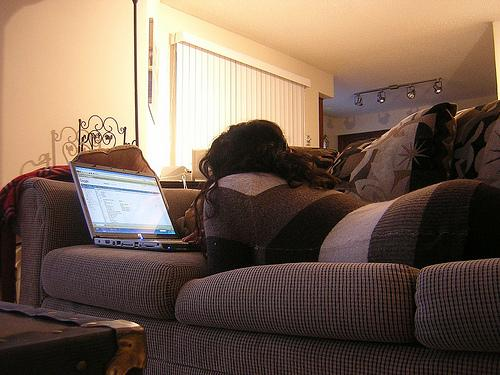Mention three key items on or by the couch other than the woman and the laptop. Pillows, a red and black blanket on the arm of the couch, and a gold star on a couch pillow. Identify the primary activity that the woman is engaged in. A woman is lying on a couch using her laptop. Mention three objects present on the couch along with the woman. A silver laptop, brown couch cushions, and patterned throw pillows. Describe the appearance and location of the window covering. White vertical blinds cover a doorway and a window, located behind the woman. What is the color and pattern of the throw pillows on the couch? The throw pillows have a brown, black, grey, and tan checkered pattern. Describe the appearance of the woman's hair and sweater. The woman has wavy black hair and is wearing a brown, black, and white striped sweater. Comment on the image's overall sentiment in relation to the position and actions of the central subject. The image conveys a sense of comfort and relaxation as the woman is lying on a couch using her laptop in a cozy space. Count the total number of cushions and pillows visible in the image. There are two brown couch cushions and two patterned throw pillows. Identify the type of table visible in the image and its position. There is a trunk coffee table near the floor, partially visible behind the couch. State the type of lighting used in the room along with their position. There are track lights and can lights hanging from the ceiling. What is the sentiment of the image? Is it positive, negative, or neutral? Neutral What color is the wall in the image?  Cream-colored What is the color of the woman's hair in the image?  Black Which items mentioned in the image have a width greater than 200?  Woman laying on a couch, woman using a laptop, laptop on a couch, girl on couch using laptop, brown and black checkered couch, woman on her stomach on a couch, a lady looking at a laptop, woman laying on a couch using her laptop, and fluffy brown couch cushions. Given these options, what is most likely the object referred to as "this is the pillow": (A) window blinds, (B) couch cushions, (C) decorative pillows, or (D) laptop? (C) decorative pillows How is the woman interacting with the laptop?  She is laying on the couch using her laptop.  What do the decorative couch pillows look like?  Brown, black, grey, and tan patterned throw pillows What type of table is visible in the image?  Trunk coffee table Identify any anomaly or unusual object in the image. There are no anomalies or unusual objects.  What type of object is directly below the track lighting?  Woman laying on a couch What is the main object a woman is interacting with in the image?  Laptop What text is visible in the image?  There is no visible text. In the image, are the couch cushions brown or green?  Brown Is the laptop on or off in the image?  On Rate the quality of the image on a scale of 1 to 10, with 1 being poor and 10 being excellent. 8 Describe the scene in the image.  A woman is laying on a brown and black checkered couch using a silver laptop, surrounded by decorative pillows and under track lighting.  Identify the color of the vertical blinds covering the doorway.  White 